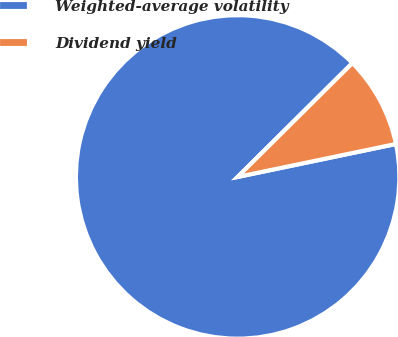<chart> <loc_0><loc_0><loc_500><loc_500><pie_chart><fcel>Weighted-average volatility<fcel>Dividend yield<nl><fcel>90.83%<fcel>9.17%<nl></chart> 